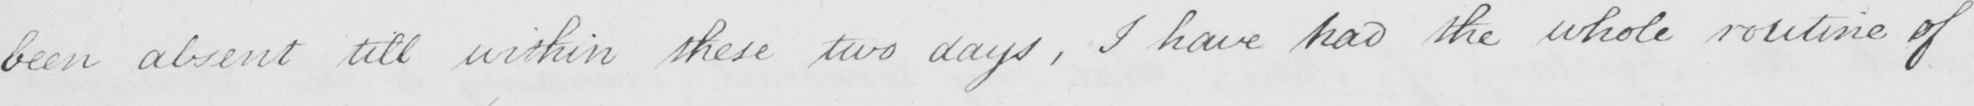Can you tell me what this handwritten text says? been absent till within these two days , I have had the whole routine of 